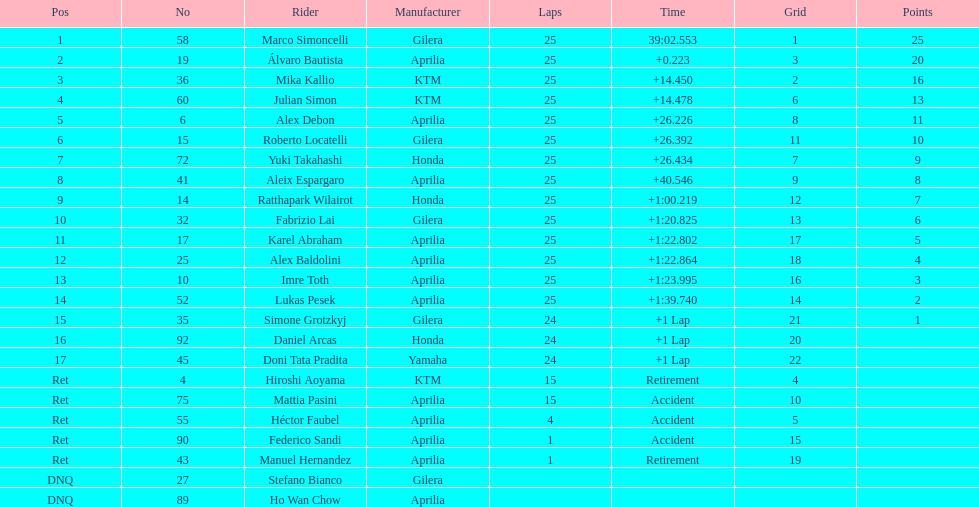How many riders does honda create? 3. 